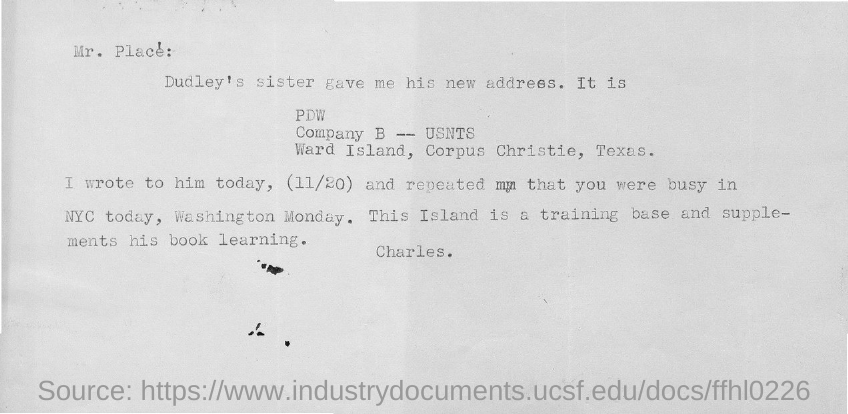Specify some key components in this picture. The date mentioned in the document is November 20th. 